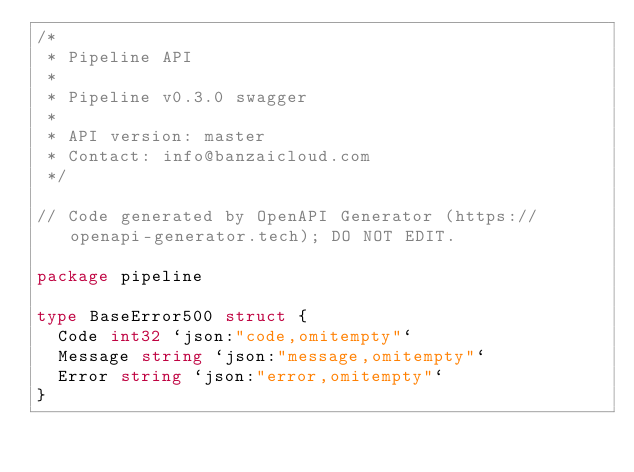<code> <loc_0><loc_0><loc_500><loc_500><_Go_>/*
 * Pipeline API
 *
 * Pipeline v0.3.0 swagger
 *
 * API version: master
 * Contact: info@banzaicloud.com
 */

// Code generated by OpenAPI Generator (https://openapi-generator.tech); DO NOT EDIT.

package pipeline

type BaseError500 struct {
	Code int32 `json:"code,omitempty"`
	Message string `json:"message,omitempty"`
	Error string `json:"error,omitempty"`
}
</code> 